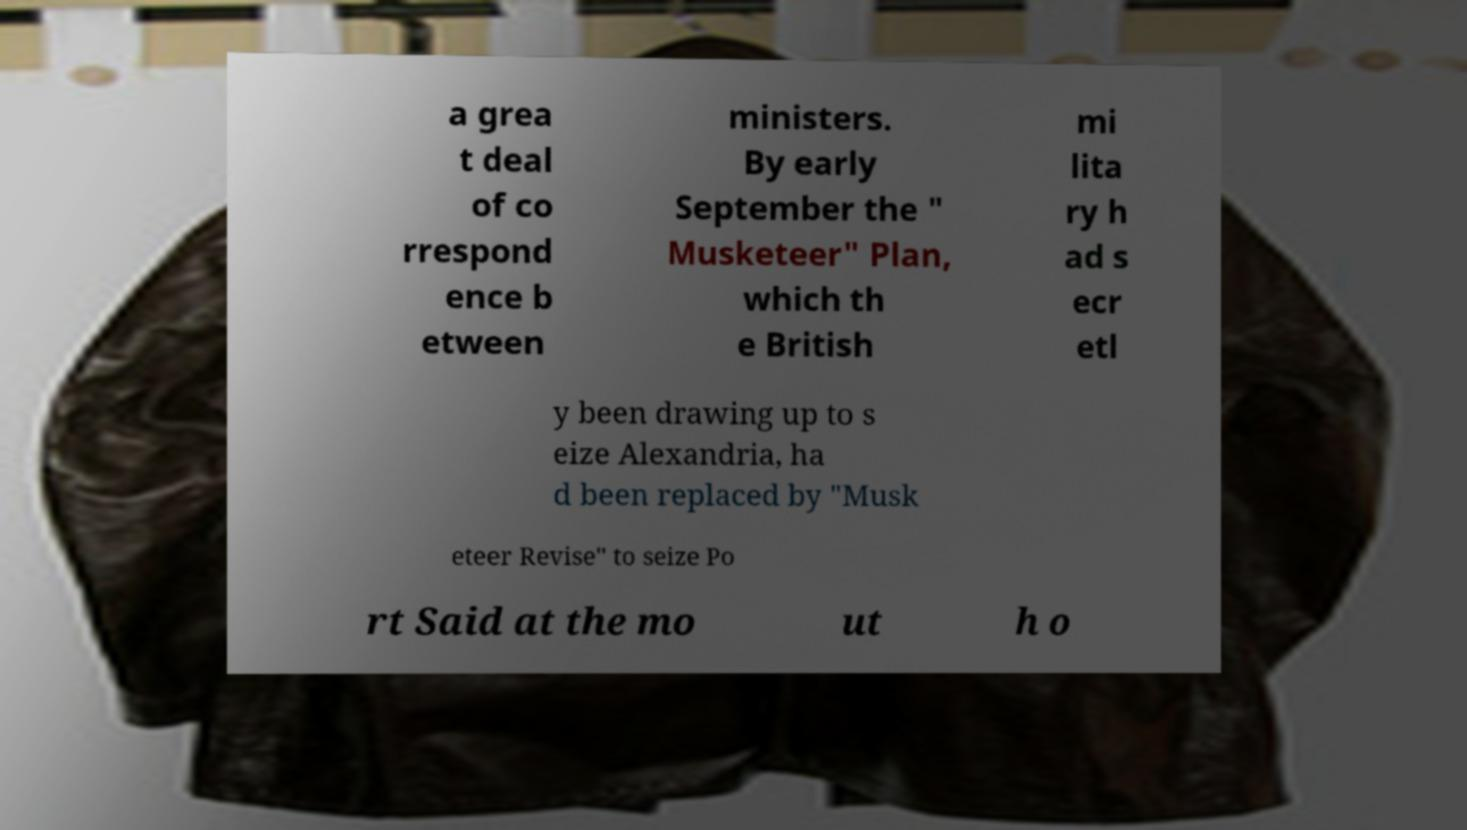I need the written content from this picture converted into text. Can you do that? a grea t deal of co rrespond ence b etween ministers. By early September the " Musketeer" Plan, which th e British mi lita ry h ad s ecr etl y been drawing up to s eize Alexandria, ha d been replaced by "Musk eteer Revise" to seize Po rt Said at the mo ut h o 